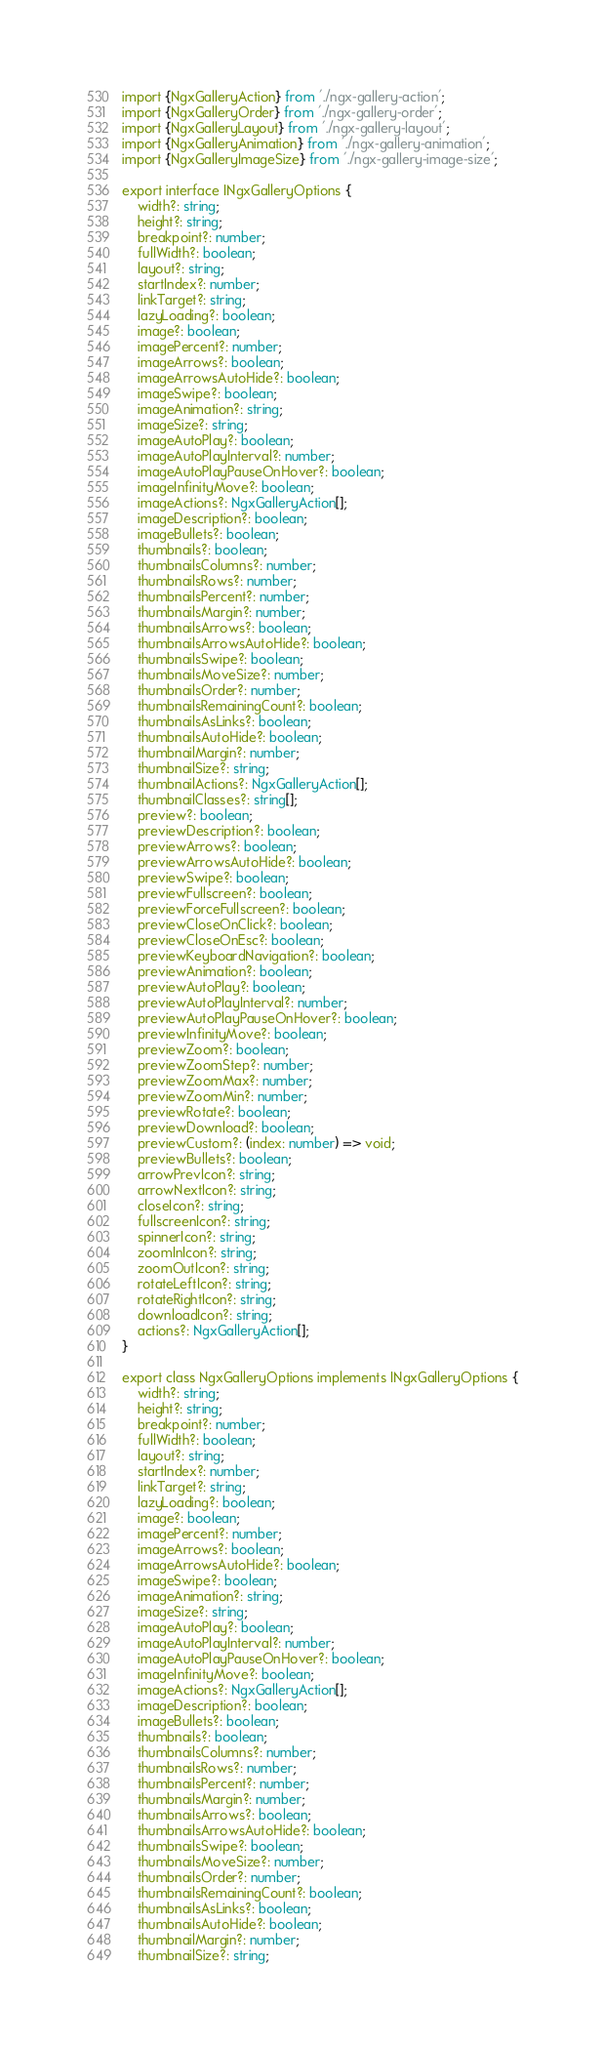<code> <loc_0><loc_0><loc_500><loc_500><_TypeScript_>import {NgxGalleryAction} from './ngx-gallery-action';
import {NgxGalleryOrder} from './ngx-gallery-order';
import {NgxGalleryLayout} from './ngx-gallery-layout';
import {NgxGalleryAnimation} from './ngx-gallery-animation';
import {NgxGalleryImageSize} from './ngx-gallery-image-size';

export interface INgxGalleryOptions {
    width?: string;
    height?: string;
    breakpoint?: number;
    fullWidth?: boolean;
    layout?: string;
    startIndex?: number;
    linkTarget?: string;
    lazyLoading?: boolean;
    image?: boolean;
    imagePercent?: number;
    imageArrows?: boolean;
    imageArrowsAutoHide?: boolean;
    imageSwipe?: boolean;
    imageAnimation?: string;
    imageSize?: string;
    imageAutoPlay?: boolean;
    imageAutoPlayInterval?: number;
    imageAutoPlayPauseOnHover?: boolean;
    imageInfinityMove?: boolean;
    imageActions?: NgxGalleryAction[];
    imageDescription?: boolean;
    imageBullets?: boolean;
    thumbnails?: boolean;
    thumbnailsColumns?: number;
    thumbnailsRows?: number;
    thumbnailsPercent?: number;
    thumbnailsMargin?: number;
    thumbnailsArrows?: boolean;
    thumbnailsArrowsAutoHide?: boolean;
    thumbnailsSwipe?: boolean;
    thumbnailsMoveSize?: number;
    thumbnailsOrder?: number;
    thumbnailsRemainingCount?: boolean;
    thumbnailsAsLinks?: boolean;
    thumbnailsAutoHide?: boolean;
    thumbnailMargin?: number;
    thumbnailSize?: string;
    thumbnailActions?: NgxGalleryAction[];
    thumbnailClasses?: string[];
    preview?: boolean;
    previewDescription?: boolean;
    previewArrows?: boolean;
    previewArrowsAutoHide?: boolean;
    previewSwipe?: boolean;
    previewFullscreen?: boolean;
    previewForceFullscreen?: boolean;
    previewCloseOnClick?: boolean;
    previewCloseOnEsc?: boolean;
    previewKeyboardNavigation?: boolean;
    previewAnimation?: boolean;
    previewAutoPlay?: boolean;
    previewAutoPlayInterval?: number;
    previewAutoPlayPauseOnHover?: boolean;
    previewInfinityMove?: boolean;
    previewZoom?: boolean;
    previewZoomStep?: number;
    previewZoomMax?: number;
    previewZoomMin?: number;
    previewRotate?: boolean;
    previewDownload?: boolean;
    previewCustom?: (index: number) => void;
    previewBullets?: boolean;
    arrowPrevIcon?: string;
    arrowNextIcon?: string;
    closeIcon?: string;
    fullscreenIcon?: string;
    spinnerIcon?: string;
    zoomInIcon?: string;
    zoomOutIcon?: string;
    rotateLeftIcon?: string;
    rotateRightIcon?: string;
    downloadIcon?: string;
    actions?: NgxGalleryAction[];
}

export class NgxGalleryOptions implements INgxGalleryOptions {
    width?: string;
    height?: string;
    breakpoint?: number;
    fullWidth?: boolean;
    layout?: string;
    startIndex?: number;
    linkTarget?: string;
    lazyLoading?: boolean;
    image?: boolean;
    imagePercent?: number;
    imageArrows?: boolean;
    imageArrowsAutoHide?: boolean;
    imageSwipe?: boolean;
    imageAnimation?: string;
    imageSize?: string;
    imageAutoPlay?: boolean;
    imageAutoPlayInterval?: number;
    imageAutoPlayPauseOnHover?: boolean;
    imageInfinityMove?: boolean;
    imageActions?: NgxGalleryAction[];
    imageDescription?: boolean;
    imageBullets?: boolean;
    thumbnails?: boolean;
    thumbnailsColumns?: number;
    thumbnailsRows?: number;
    thumbnailsPercent?: number;
    thumbnailsMargin?: number;
    thumbnailsArrows?: boolean;
    thumbnailsArrowsAutoHide?: boolean;
    thumbnailsSwipe?: boolean;
    thumbnailsMoveSize?: number;
    thumbnailsOrder?: number;
    thumbnailsRemainingCount?: boolean;
    thumbnailsAsLinks?: boolean;
    thumbnailsAutoHide?: boolean;
    thumbnailMargin?: number;
    thumbnailSize?: string;</code> 